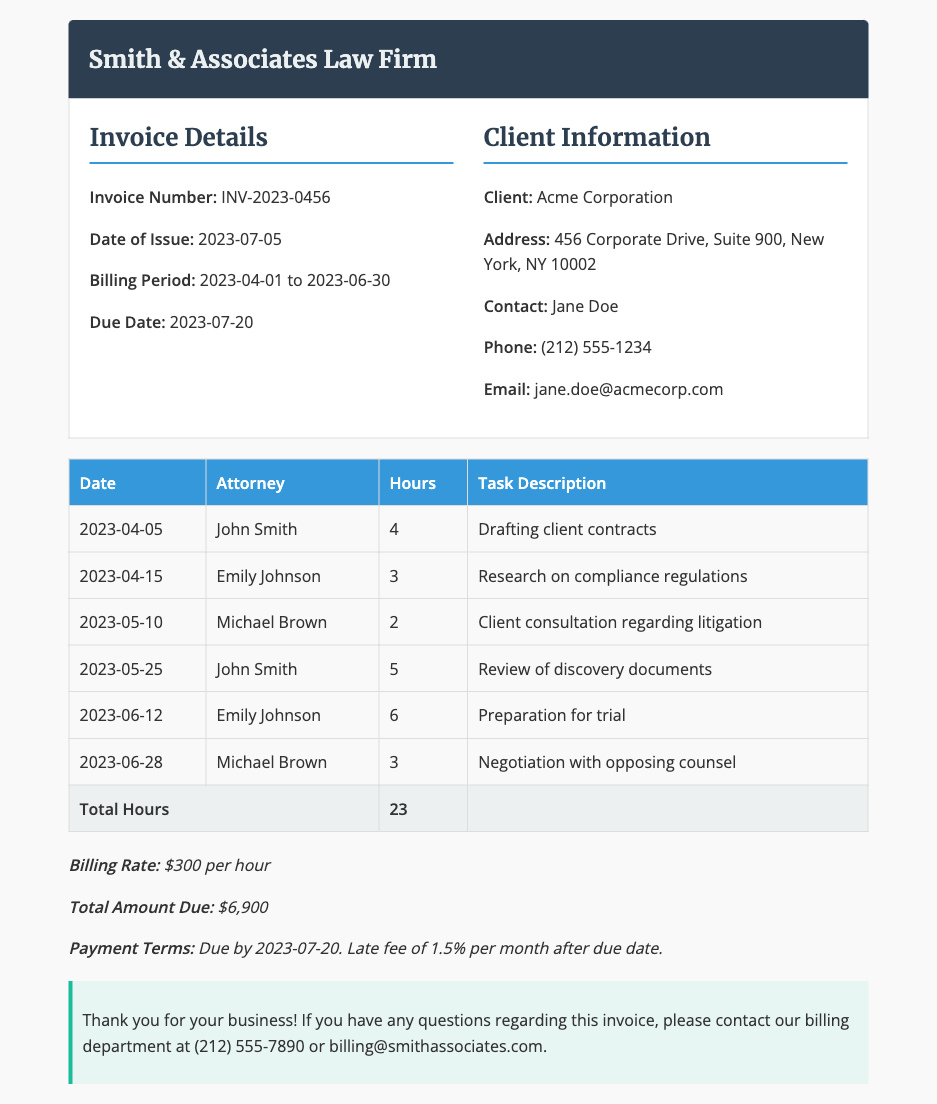What is the invoice number? The invoice number is specified under "Invoice Details" in the document.
Answer: INV-2023-0456 Who is the client? The client's name is presented in the "Client Information" section of the document.
Answer: Acme Corporation What is the total hours worked? The total hours worked is provided in the last row of the hours table in the document.
Answer: 23 What is the billing rate per hour? The billing rate is mentioned in the "Payment Terms" section of the document.
Answer: $300 per hour Who was responsible for drafting client contracts? The attorney assigned to this task is listed under the "Attorney" column for the respective date.
Answer: John Smith What is the due date for payment? The due date is indicated in the "Invoice Details" section.
Answer: 2023-07-20 How many hours did Emily Johnson work in total? To find this, we sum up the hours recorded under Emily Johnson's entries in the table.
Answer: 9 What is the total amount due? This amount is presented in the "Payment Terms" section of the document.
Answer: $6,900 What task was performed on 2023-06-12? The task for this date is mentioned in the "Task Description" column of the respective row.
Answer: Preparation for trial 